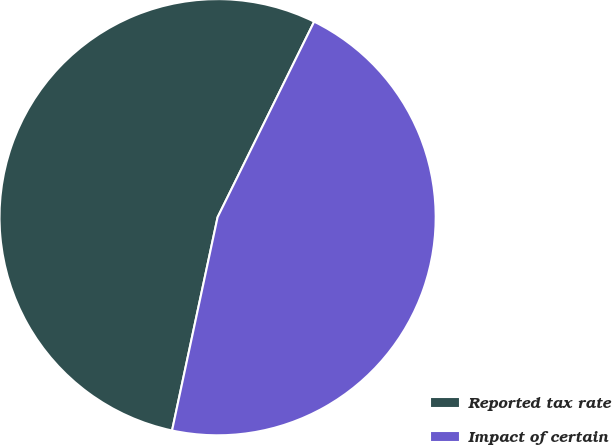<chart> <loc_0><loc_0><loc_500><loc_500><pie_chart><fcel>Reported tax rate<fcel>Impact of certain<nl><fcel>53.95%<fcel>46.05%<nl></chart> 